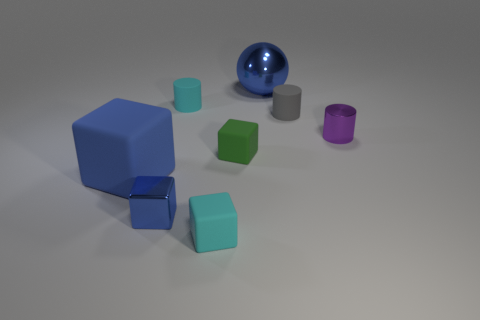Subtract all small cubes. How many cubes are left? 1 Add 1 small gray matte cylinders. How many objects exist? 9 Subtract all cylinders. How many objects are left? 5 Subtract 2 cylinders. How many cylinders are left? 1 Subtract all purple cylinders. Subtract all green spheres. How many cylinders are left? 2 Subtract all purple balls. How many green cylinders are left? 0 Subtract all yellow cubes. Subtract all cyan things. How many objects are left? 6 Add 4 large blue shiny objects. How many large blue shiny objects are left? 5 Add 2 tiny gray matte things. How many tiny gray matte things exist? 3 Subtract all green blocks. How many blocks are left? 3 